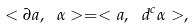Convert formula to latex. <formula><loc_0><loc_0><loc_500><loc_500>< \partial a , \ \alpha > = < a , \ d ^ { c } \alpha > ,</formula> 